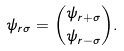<formula> <loc_0><loc_0><loc_500><loc_500>\psi _ { { r } \sigma } = { \psi _ { { r } + \sigma } \choose \psi _ { { r } - \sigma } } .</formula> 